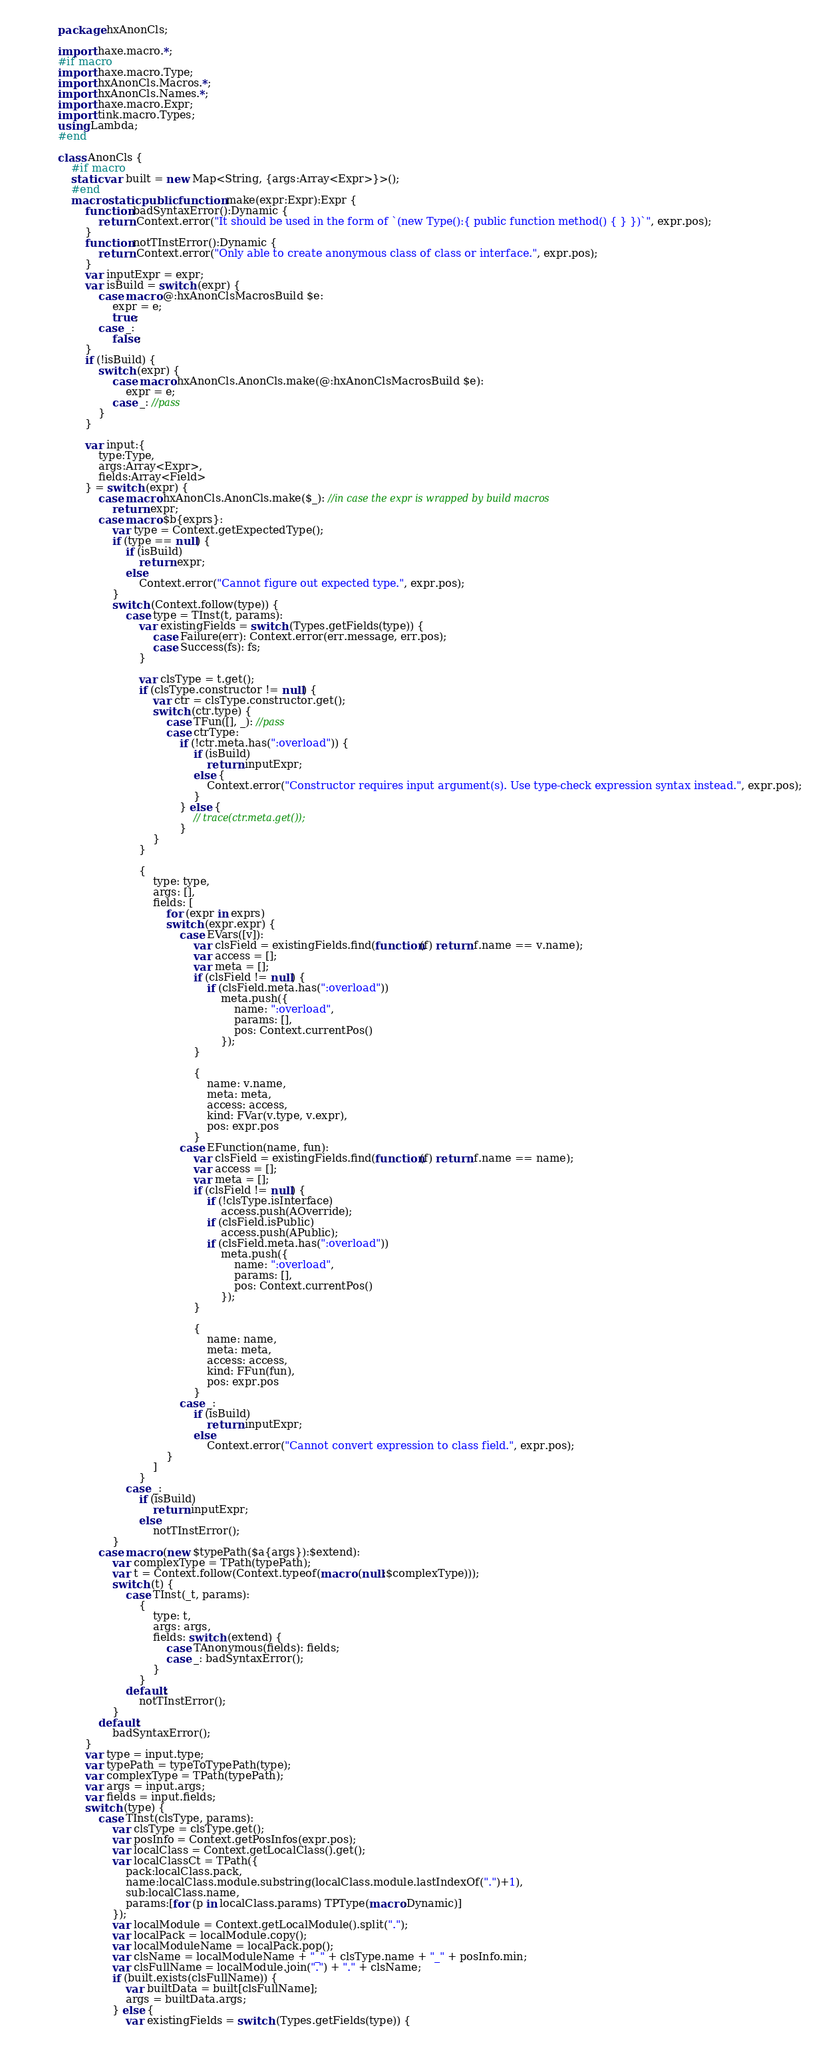Convert code to text. <code><loc_0><loc_0><loc_500><loc_500><_Haxe_>package hxAnonCls;

import haxe.macro.*;
#if macro
import haxe.macro.Type;
import hxAnonCls.Macros.*;
import hxAnonCls.Names.*;
import haxe.macro.Expr;
import tink.macro.Types;
using Lambda;
#end

class AnonCls {
	#if macro
	static var built = new Map<String, {args:Array<Expr>}>();
	#end
	macro static public function make(expr:Expr):Expr {
		function badSyntaxError():Dynamic {
			return Context.error("It should be used in the form of `(new Type():{ public function method() { } })`", expr.pos);
		}
		function notTInstError():Dynamic {
			return Context.error("Only able to create anonymous class of class or interface.", expr.pos);
		}
		var inputExpr = expr;
		var isBuild = switch (expr) {
			case macro @:hxAnonClsMacrosBuild $e:
				expr = e;
				true;
			case _:
				false;
		}
		if (!isBuild) {
			switch (expr) {
				case macro hxAnonCls.AnonCls.make(@:hxAnonClsMacrosBuild $e):
					expr = e;
				case _: //pass
			}
		}

		var input:{
			type:Type,
			args:Array<Expr>,
			fields:Array<Field>
		} = switch (expr) {
			case macro hxAnonCls.AnonCls.make($_): //in case the expr is wrapped by build macros
				return expr;
			case macro $b{exprs}:
				var type = Context.getExpectedType();
				if (type == null) {
					if (isBuild)
						return expr;
					else
						Context.error("Cannot figure out expected type.", expr.pos);
				}
				switch (Context.follow(type)) {
					case type = TInst(t, params):
						var existingFields = switch (Types.getFields(type)) {
							case Failure(err): Context.error(err.message, err.pos);
							case Success(fs): fs;
						}

						var clsType = t.get();
						if (clsType.constructor != null) {
							var ctr = clsType.constructor.get();
							switch (ctr.type) {
								case TFun([], _): //pass
								case ctrType:
									if (!ctr.meta.has(":overload")) {
										if (isBuild)
											return inputExpr;
										else {
											Context.error("Constructor requires input argument(s). Use type-check expression syntax instead.", expr.pos);
										}
									} else {
										// trace(ctr.meta.get());
									}
							}
						}

						{
							type: type,
							args: [],
							fields: [
								for (expr in exprs)
								switch (expr.expr) {
									case EVars([v]):
										var clsField = existingFields.find(function(f) return f.name == v.name);
										var access = [];
										var meta = [];
										if (clsField != null) {
											if (clsField.meta.has(":overload"))
												meta.push({
													name: ":overload",
													params: [],
													pos: Context.currentPos()
												});
										}

										{
											name: v.name,
											meta: meta,
											access: access,
											kind: FVar(v.type, v.expr),
											pos: expr.pos
										}
									case EFunction(name, fun):
										var clsField = existingFields.find(function(f) return f.name == name);
										var access = [];
										var meta = [];
										if (clsField != null) {
											if (!clsType.isInterface)
												access.push(AOverride);
											if (clsField.isPublic)
												access.push(APublic);
											if (clsField.meta.has(":overload"))
												meta.push({
													name: ":overload",
													params: [],
													pos: Context.currentPos()
												});
										}

										{
											name: name,
											meta: meta,
											access: access,
											kind: FFun(fun),
											pos: expr.pos
										}
									case _:
										if (isBuild)
											return inputExpr;
										else
											Context.error("Cannot convert expression to class field.", expr.pos);
								}
							]
						}
					case _:
						if (isBuild)
							return inputExpr;
						else
							notTInstError();
				}
			case macro (new $typePath($a{args}):$extend):
				var complexType = TPath(typePath);
				var t = Context.follow(Context.typeof(macro (null:$complexType)));
				switch (t) {
					case TInst(_t, params):
						{
							type: t,
							args: args,
							fields: switch (extend) {
								case TAnonymous(fields): fields;
								case _: badSyntaxError();
							}
						}
					default:
						notTInstError();
				}
			default:
				badSyntaxError();
		}
		var type = input.type;
		var typePath = typeToTypePath(type);
		var complexType = TPath(typePath);
		var args = input.args;
		var fields = input.fields;
		switch (type) {
			case TInst(clsType, params):
				var clsType = clsType.get();
				var posInfo = Context.getPosInfos(expr.pos);
				var localClass = Context.getLocalClass().get();
				var localClassCt = TPath({
					pack:localClass.pack,
					name:localClass.module.substring(localClass.module.lastIndexOf(".")+1),
					sub:localClass.name,
					params:[for (p in localClass.params) TPType(macro:Dynamic)]
				});
				var localModule = Context.getLocalModule().split(".");
				var localPack = localModule.copy();
				var localModuleName = localPack.pop();
				var clsName = localModuleName + "_" + clsType.name + "_" + posInfo.min;
				var clsFullName = localModule.join(".") + "." + clsName;
				if (built.exists(clsFullName)) {
					var builtData = built[clsFullName];
					args = builtData.args;
				} else {
					var existingFields = switch (Types.getFields(type)) {</code> 